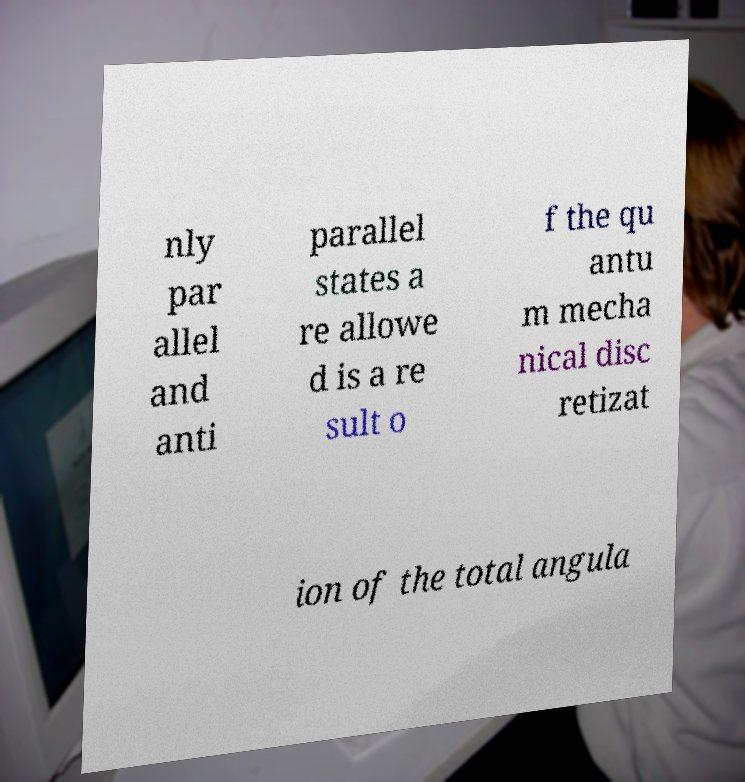For documentation purposes, I need the text within this image transcribed. Could you provide that? nly par allel and anti parallel states a re allowe d is a re sult o f the qu antu m mecha nical disc retizat ion of the total angula 